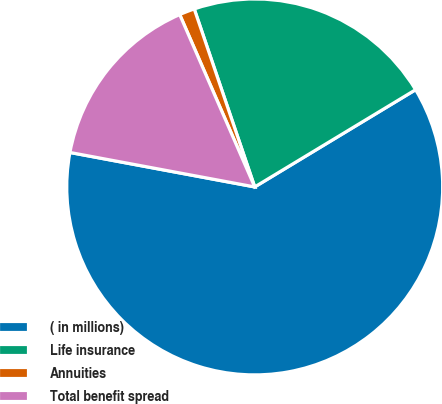Convert chart. <chart><loc_0><loc_0><loc_500><loc_500><pie_chart><fcel>( in millions)<fcel>Life insurance<fcel>Annuities<fcel>Total benefit spread<nl><fcel>61.58%<fcel>21.56%<fcel>1.32%<fcel>15.53%<nl></chart> 